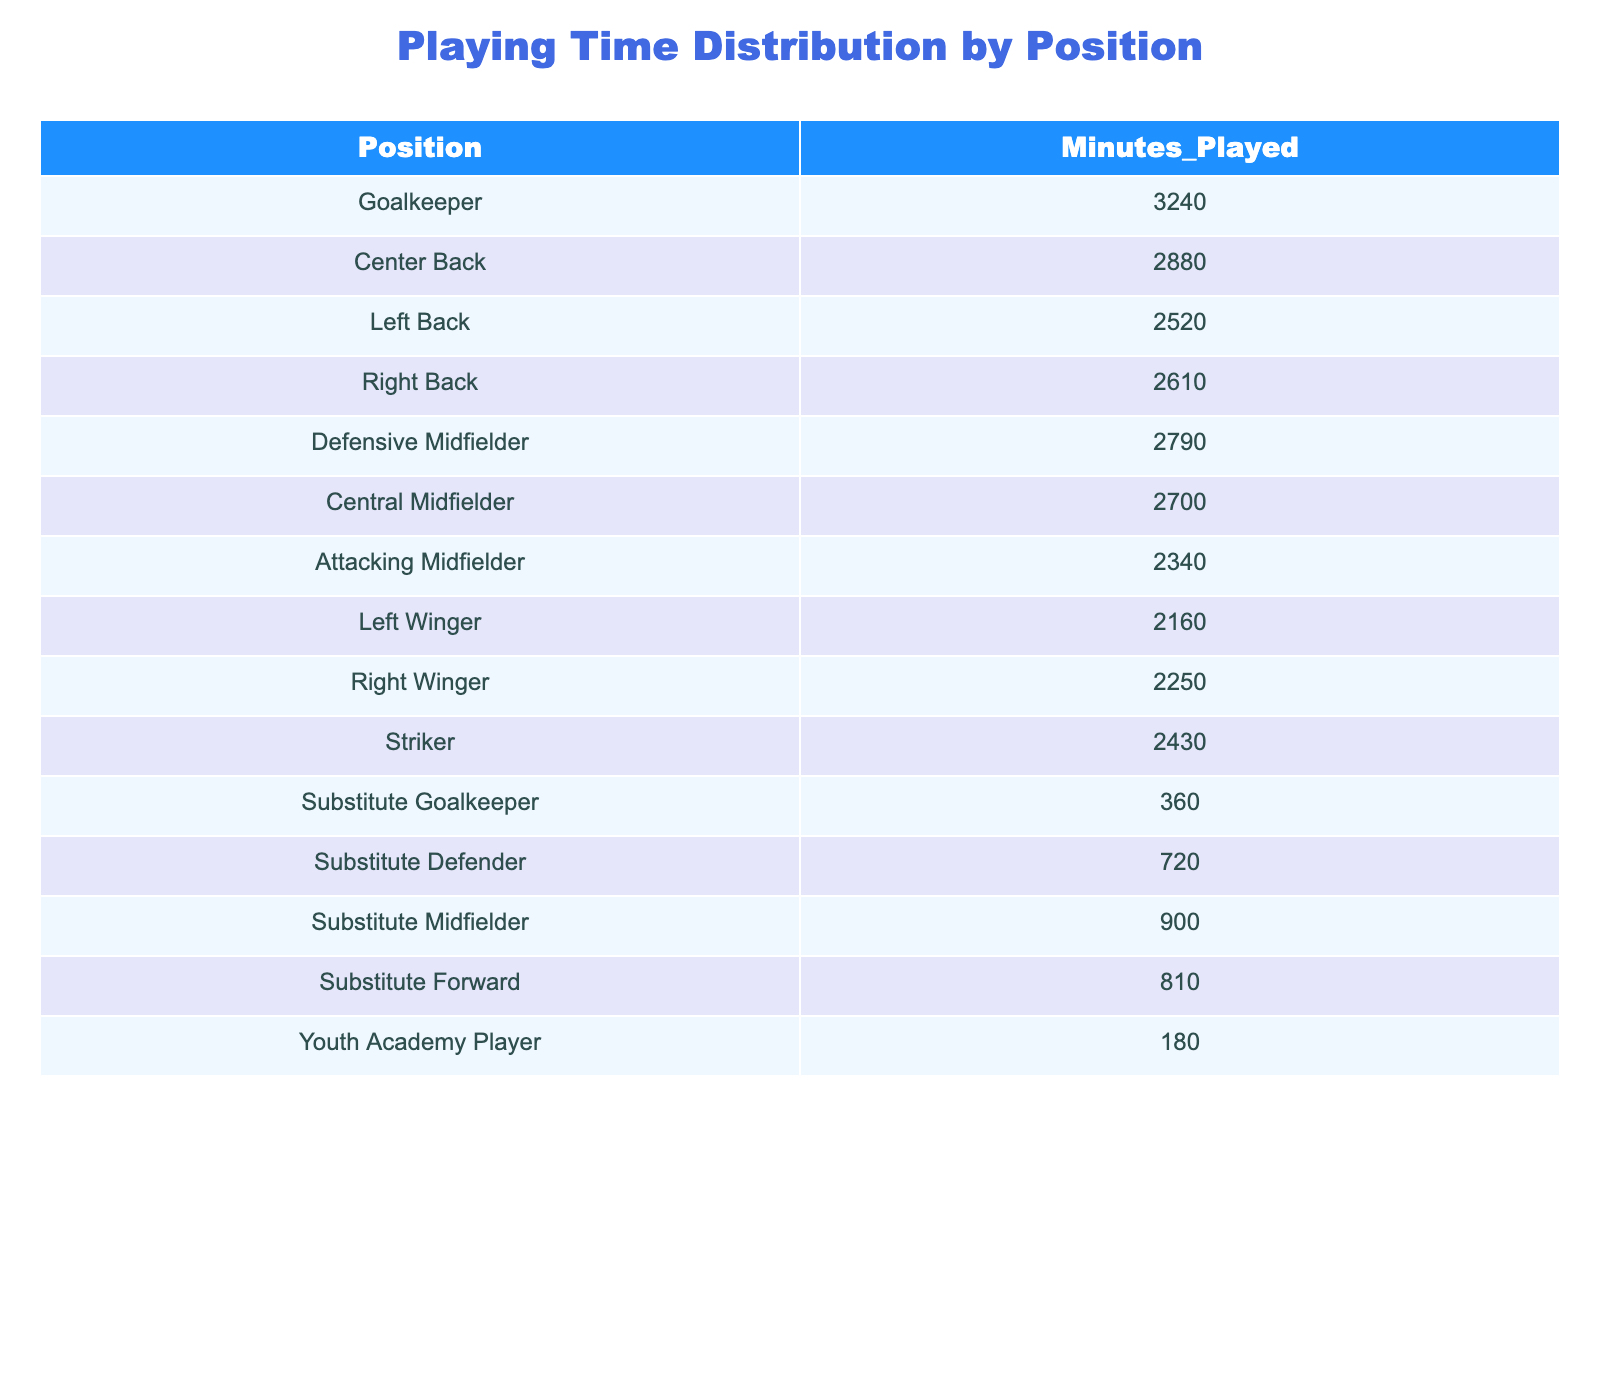What is the total playing time for all defenders? Defenders include Center Back, Left Back, Right Back, and Substitute Defender. Their minutes played are 2880, 2520, 2610, and 720 respectively. Adding these up: 2880 + 2520 + 2610 + 720 = 8730.
Answer: 8730 Which position has the least playing time? The position with the least playing time is the Youth Academy Player, with 180 minutes played, as it is the lowest value in the table.
Answer: Youth Academy Player How many more minutes did the Goalkeeper play compared to the Substitutes combined? The Goalkeeper played 3240 minutes. The total for the Substitutes (Substitute Goalkeeper, Substitute Defender, Substitute Midfielder, Substitute Forward) is 360 + 720 + 900 + 810 = 2790. The difference is 3240 - 2790 = 450.
Answer: 450 What percentage of total playing time is accounted for by the Striker position? First, calculate the total playing time: sum all minutes played, which is 3240 + 2880 + 2520 + 2610 + 2790 + 2700 + 2340 + 2160 + 2250 + 2430 + 360 + 720 + 900 + 810 + 180 = 15540. The Striker played 2430 minutes. The percentage is (2430/15540) * 100 ≈ 15.63%.
Answer: Approximately 15.63% Are there more minutes played by midfielders compared to forwards? Midfielders include Defensive Midfielder, Central Midfielder, and Attacking Midfielder with minutes 2790, 2700, and 2340 respectively, totaling 2790 + 2700 + 2340 = 7830. Forwards include Striker and Substitute Forward with minutes 2430 and 810, totaling 2430 + 810 = 3240. Since 7830 is greater than 3240, yes, midfielders have more minutes.
Answer: Yes What is the average playing time for all positions? First, calculate the total playing time which is 15540. Since there are 15 positions, the average is 15540 / 15 = 1036.
Answer: 1036 How much playing time did the Right Back and Left Back have combined? The Right Back had 2610 minutes and the Left Back had 2520 minutes. Adding them together gives 2610 + 2520 = 5130.
Answer: 5130 Is the total playing time for the two wingers greater than the total for the three midfielders? The Left Winger and Right Winger played 2160 and 2250 minutes respectively, totaling 2160 + 2250 = 4410. The three midfielders (Defensive, Central, and Attacking) played 2790, 2700, and 2340 minutes, totaling 2790 + 2700 + 2340 = 7830. Since 4410 is less than 7830, the answer is no.
Answer: No 